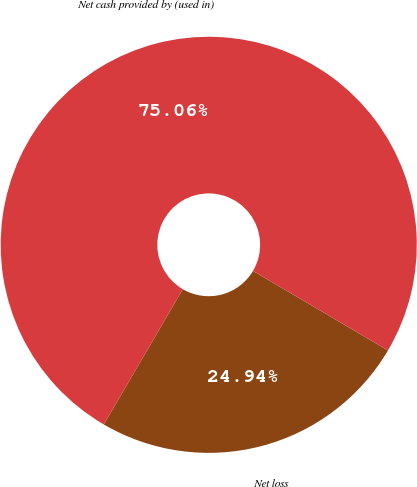Convert chart. <chart><loc_0><loc_0><loc_500><loc_500><pie_chart><fcel>Net loss<fcel>Net cash provided by (used in)<nl><fcel>24.94%<fcel>75.06%<nl></chart> 